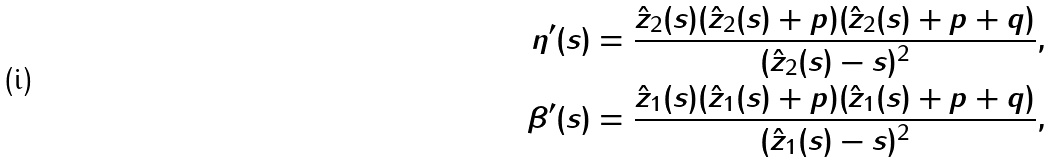<formula> <loc_0><loc_0><loc_500><loc_500>\eta ^ { \prime } ( s ) & = \frac { \hat { z } _ { 2 } ( s ) ( \hat { z } _ { 2 } ( s ) + p ) ( \hat { z } _ { 2 } ( s ) + p + q ) } { ( \hat { z } _ { 2 } ( s ) - s ) ^ { 2 } } , \\ \beta ^ { \prime } ( s ) & = \frac { \hat { z } _ { 1 } ( s ) ( \hat { z } _ { 1 } ( s ) + p ) ( \hat { z } _ { 1 } ( s ) + p + q ) } { ( \hat { z } _ { 1 } ( s ) - s ) ^ { 2 } } ,</formula> 